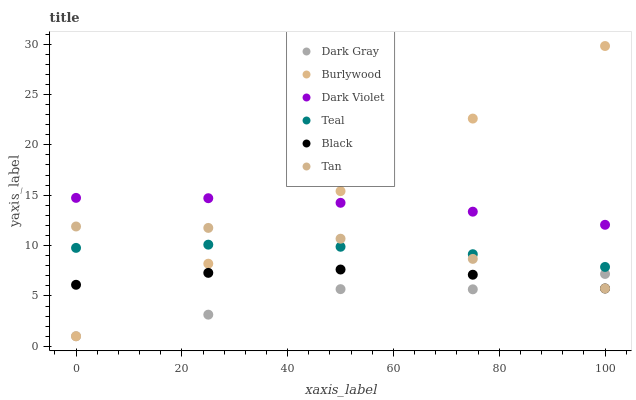Does Dark Gray have the minimum area under the curve?
Answer yes or no. Yes. Does Burlywood have the maximum area under the curve?
Answer yes or no. Yes. Does Dark Violet have the minimum area under the curve?
Answer yes or no. No. Does Dark Violet have the maximum area under the curve?
Answer yes or no. No. Is Burlywood the smoothest?
Answer yes or no. Yes. Is Dark Gray the roughest?
Answer yes or no. Yes. Is Dark Violet the smoothest?
Answer yes or no. No. Is Dark Violet the roughest?
Answer yes or no. No. Does Burlywood have the lowest value?
Answer yes or no. Yes. Does Dark Violet have the lowest value?
Answer yes or no. No. Does Burlywood have the highest value?
Answer yes or no. Yes. Does Dark Violet have the highest value?
Answer yes or no. No. Is Black less than Dark Violet?
Answer yes or no. Yes. Is Dark Violet greater than Black?
Answer yes or no. Yes. Does Burlywood intersect Black?
Answer yes or no. Yes. Is Burlywood less than Black?
Answer yes or no. No. Is Burlywood greater than Black?
Answer yes or no. No. Does Black intersect Dark Violet?
Answer yes or no. No. 